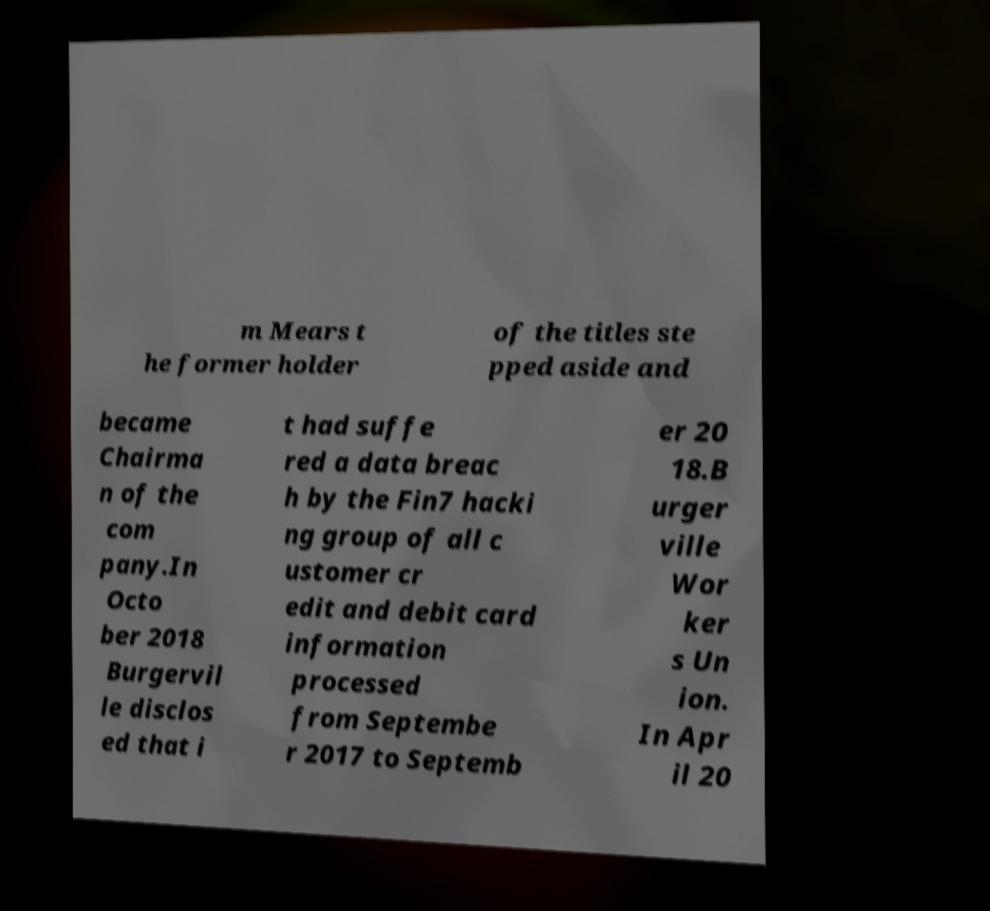For documentation purposes, I need the text within this image transcribed. Could you provide that? m Mears t he former holder of the titles ste pped aside and became Chairma n of the com pany.In Octo ber 2018 Burgervil le disclos ed that i t had suffe red a data breac h by the Fin7 hacki ng group of all c ustomer cr edit and debit card information processed from Septembe r 2017 to Septemb er 20 18.B urger ville Wor ker s Un ion. In Apr il 20 